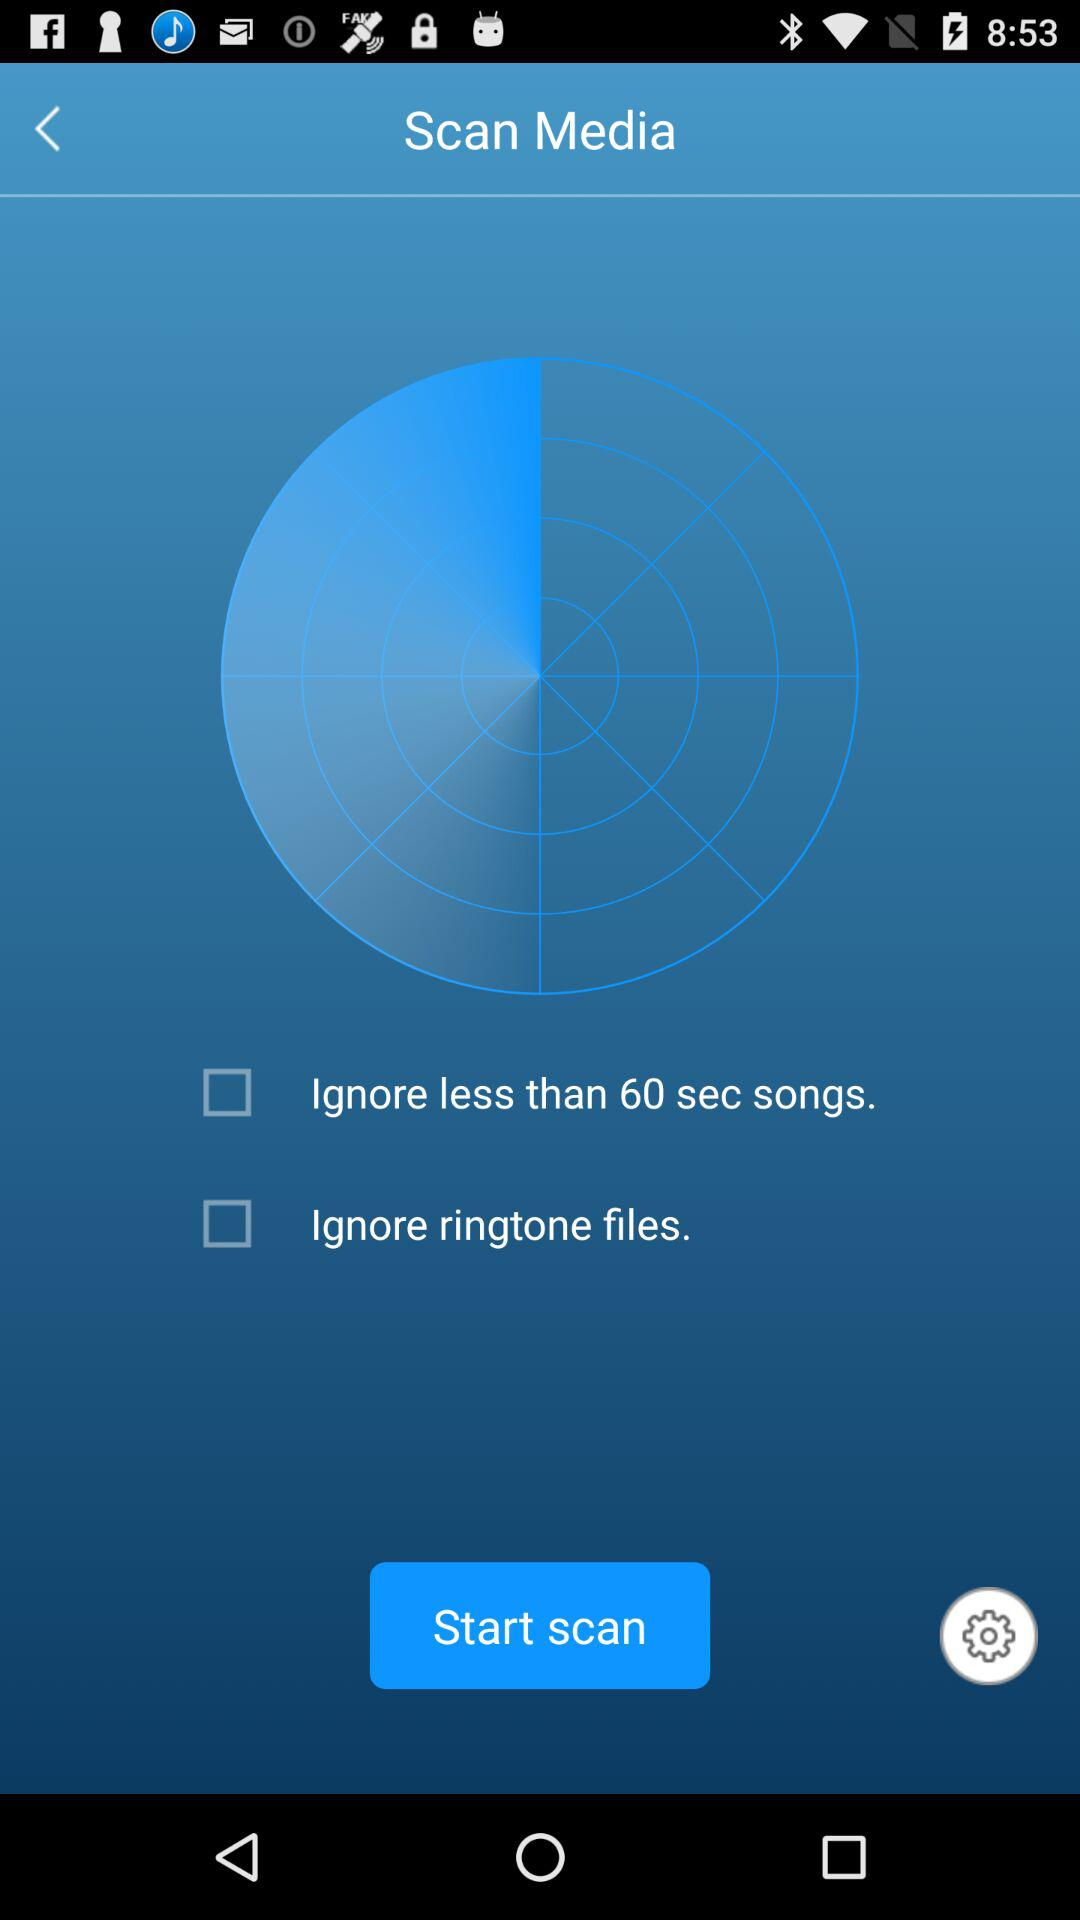What is the status of "Ignore less than 60 sec songs"? The status is "off". 